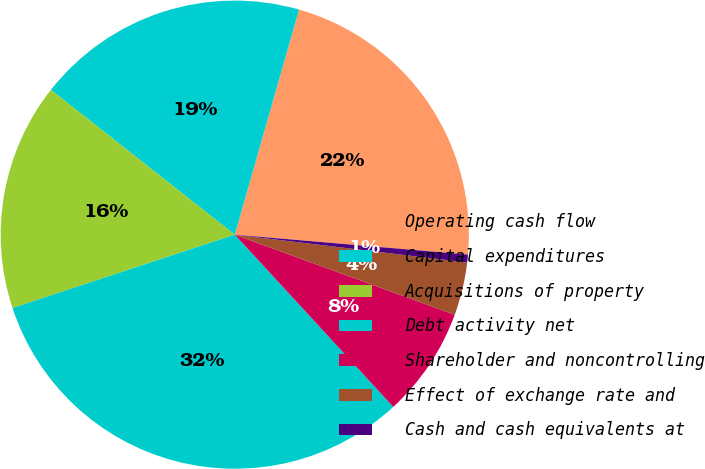<chart> <loc_0><loc_0><loc_500><loc_500><pie_chart><fcel>Operating cash flow<fcel>Capital expenditures<fcel>Acquisitions of property<fcel>Debt activity net<fcel>Shareholder and noncontrolling<fcel>Effect of exchange rate and<fcel>Cash and cash equivalents at<nl><fcel>21.93%<fcel>18.81%<fcel>15.69%<fcel>31.76%<fcel>7.6%<fcel>3.66%<fcel>0.54%<nl></chart> 